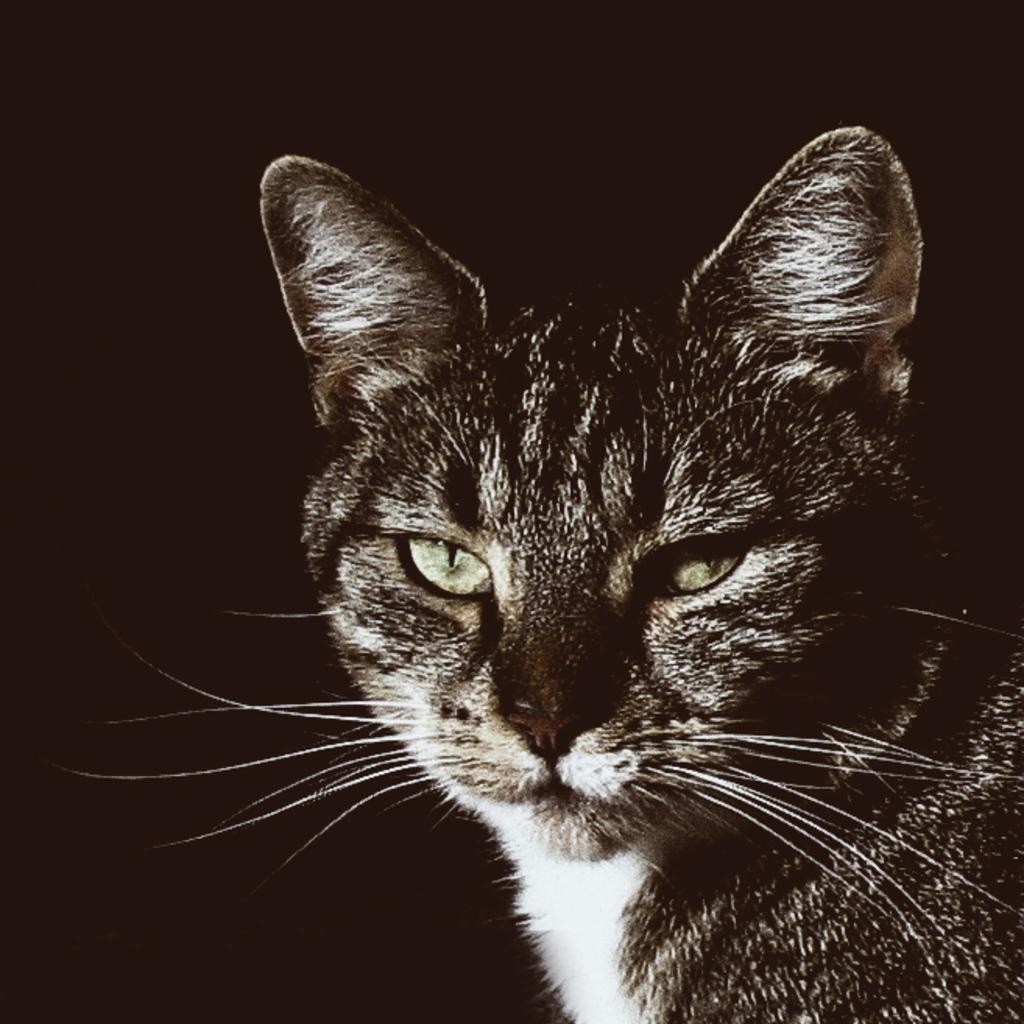What type of animal is in the image? There is a cat in the image. What can be observed about the background of the image? The background of the image is dark. What type of food does the cat enjoy in the image? There is no information about the cat's food preferences in the image. What hobbies does the cat have, as depicted in the image? There is no information about the cat's hobbies in the image. 